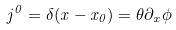<formula> <loc_0><loc_0><loc_500><loc_500>j ^ { 0 } = \delta ( x - x _ { 0 } ) = \theta \partial _ { x } \phi</formula> 